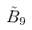<formula> <loc_0><loc_0><loc_500><loc_500>\tilde { B } _ { 9 }</formula> 